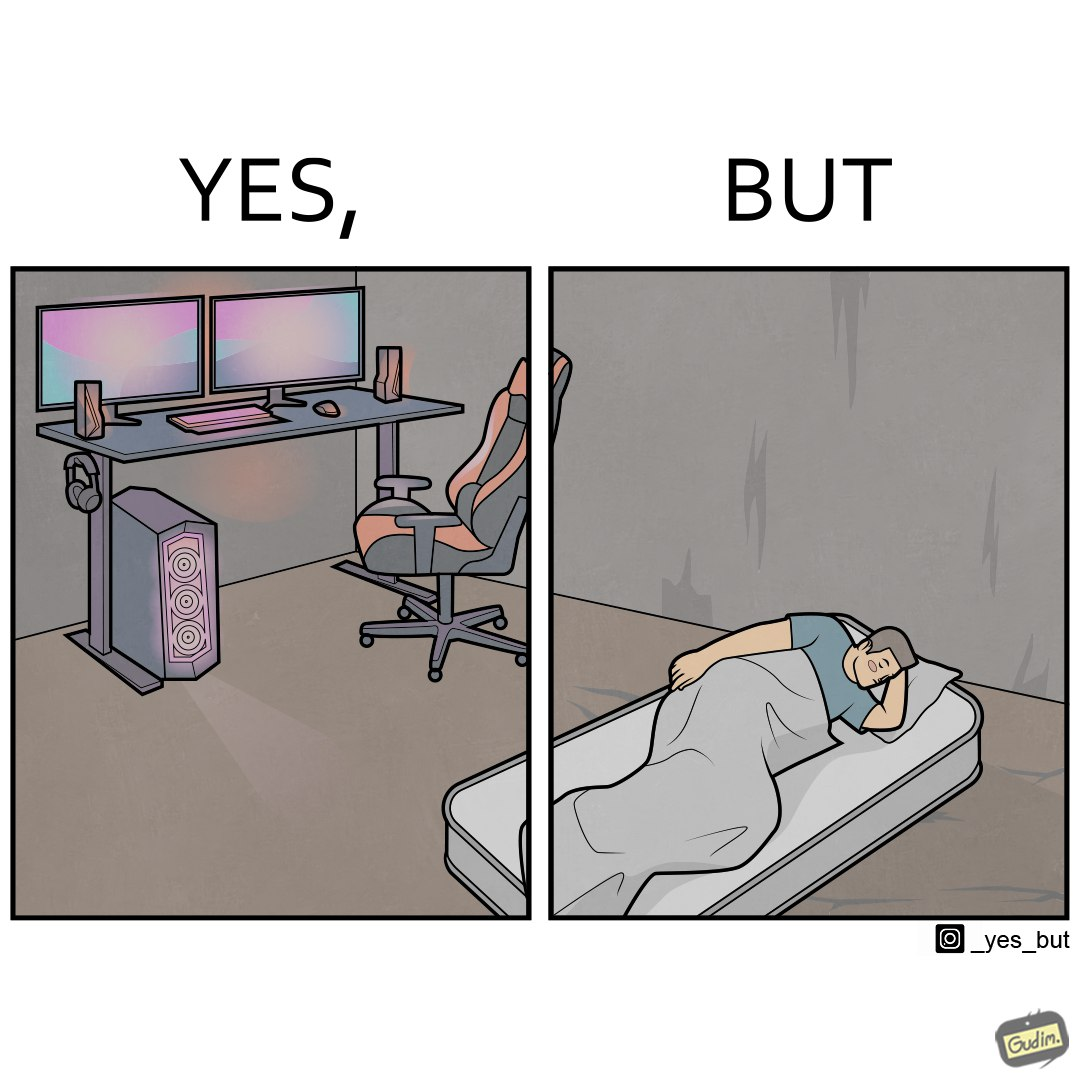Describe the content of this image. The image is funny because the person has a lot of furniture for his computer but none for himself. 